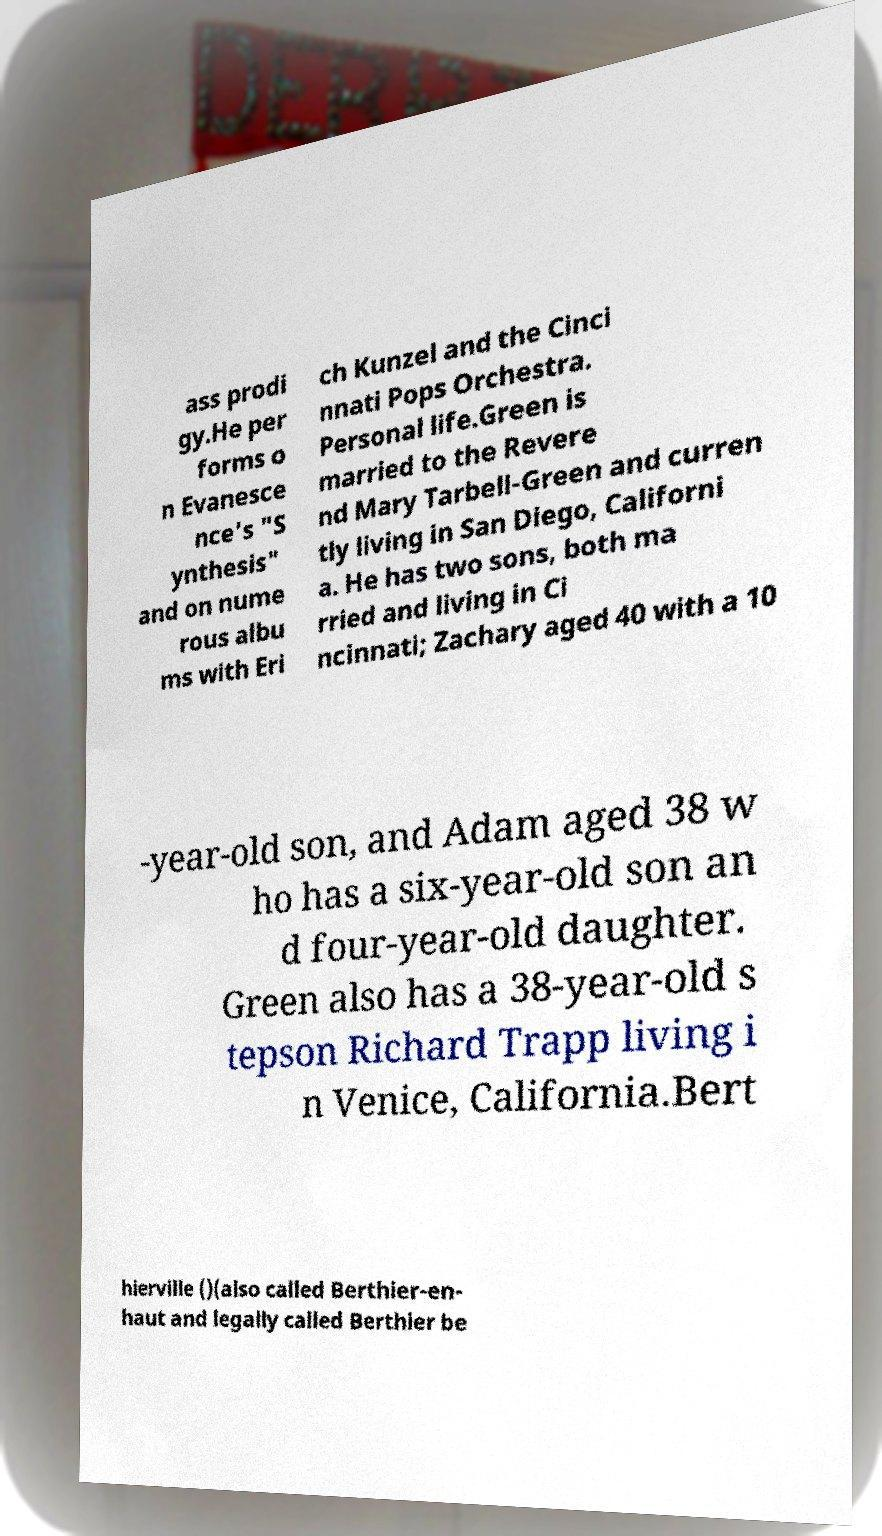For documentation purposes, I need the text within this image transcribed. Could you provide that? ass prodi gy.He per forms o n Evanesce nce's "S ynthesis" and on nume rous albu ms with Eri ch Kunzel and the Cinci nnati Pops Orchestra. Personal life.Green is married to the Revere nd Mary Tarbell-Green and curren tly living in San Diego, Californi a. He has two sons, both ma rried and living in Ci ncinnati; Zachary aged 40 with a 10 -year-old son, and Adam aged 38 w ho has a six-year-old son an d four-year-old daughter. Green also has a 38-year-old s tepson Richard Trapp living i n Venice, California.Bert hierville ()(also called Berthier-en- haut and legally called Berthier be 